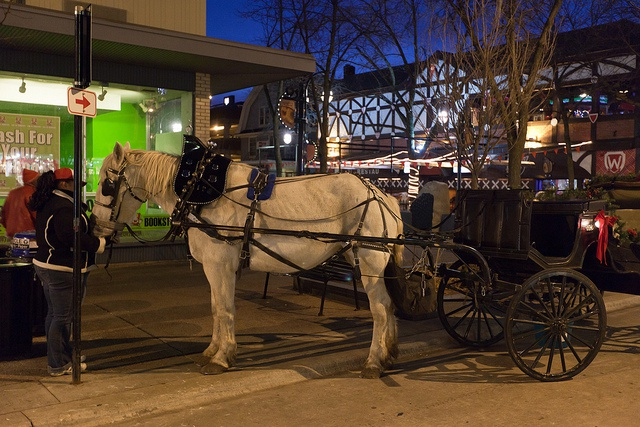Describe the objects in this image and their specific colors. I can see horse in black, gray, maroon, and tan tones, people in black, maroon, gray, and tan tones, people in black and maroon tones, and bench in black, maroon, and teal tones in this image. 